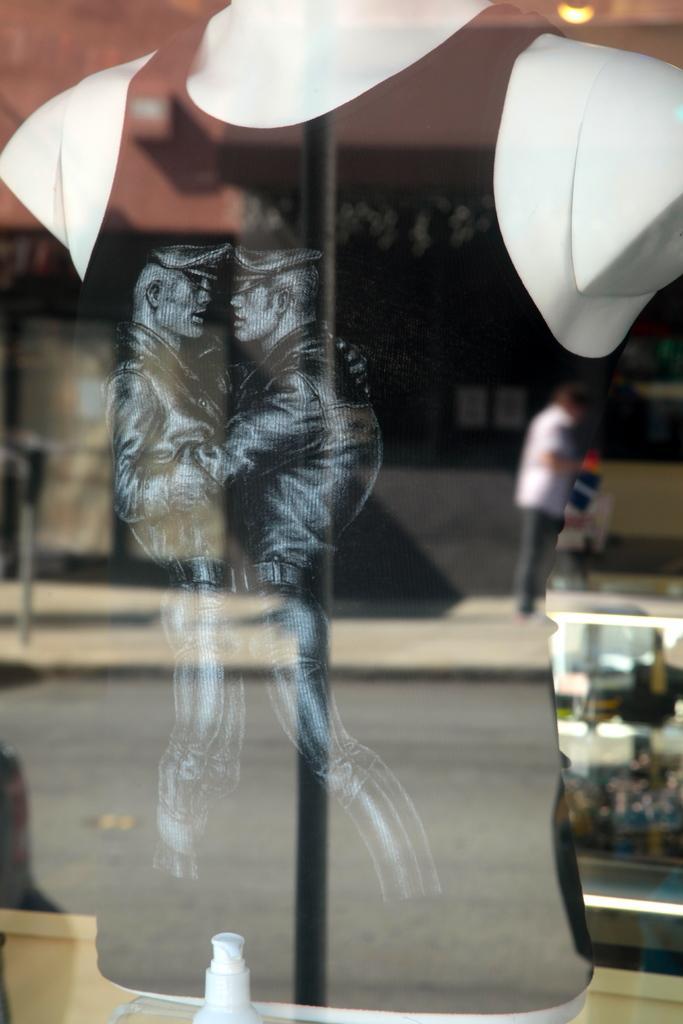In one or two sentences, can you explain what this image depicts? In the image we can see two sculptures of men wearing clothes and hat. This is a glass and in the glass we can see a reflection of a person standing wearing clothes, this is a pole and light. 